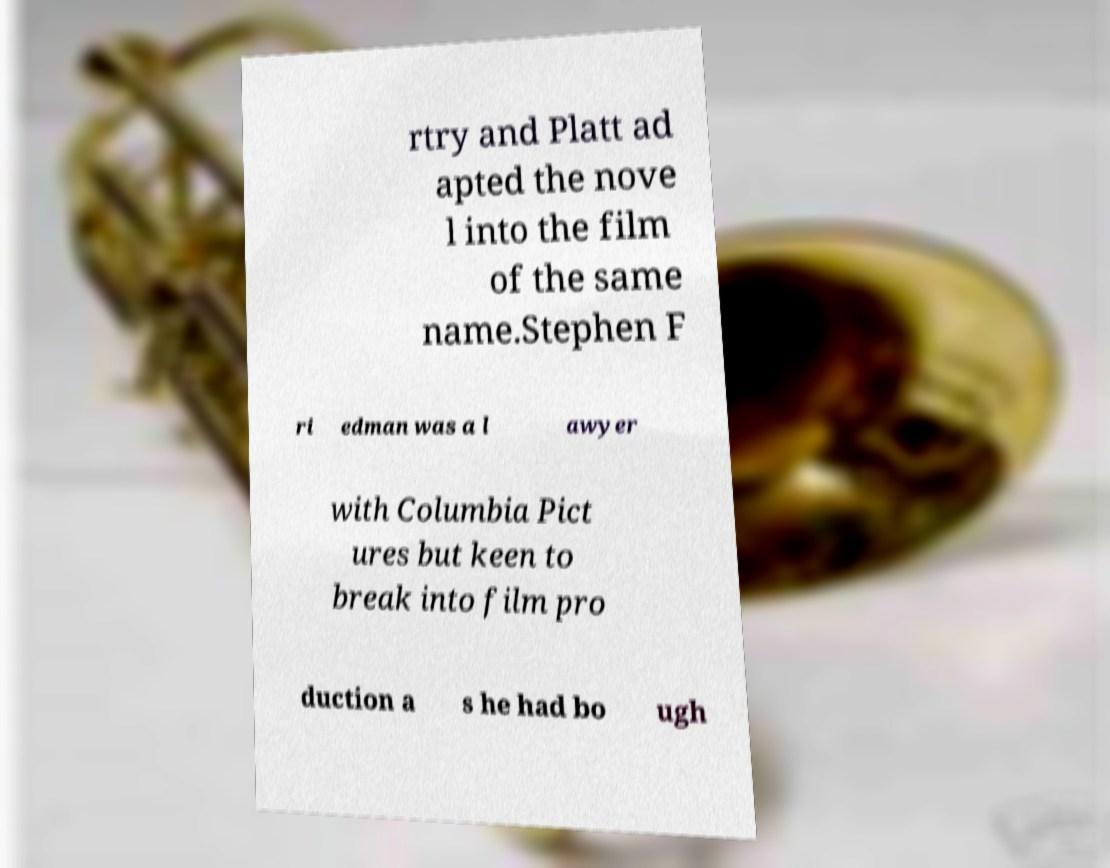For documentation purposes, I need the text within this image transcribed. Could you provide that? rtry and Platt ad apted the nove l into the film of the same name.Stephen F ri edman was a l awyer with Columbia Pict ures but keen to break into film pro duction a s he had bo ugh 